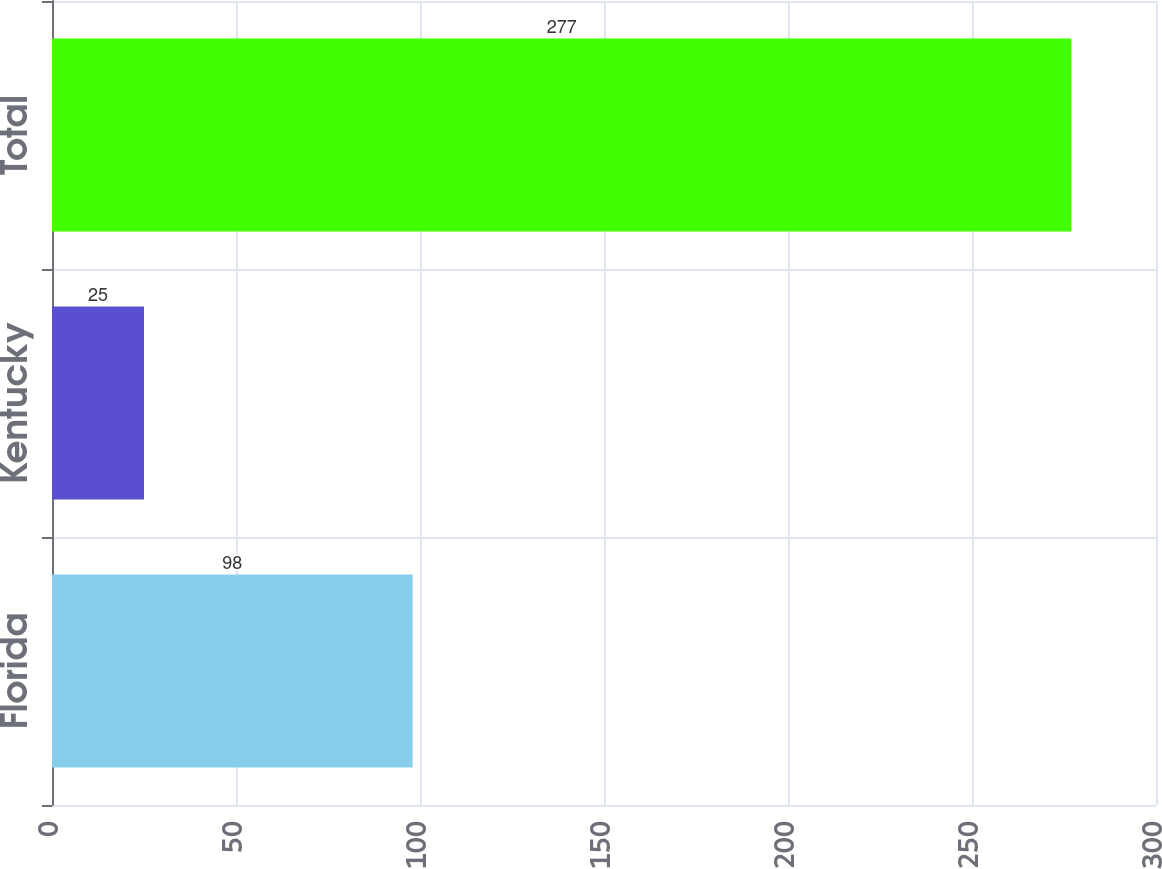Convert chart to OTSL. <chart><loc_0><loc_0><loc_500><loc_500><bar_chart><fcel>Florida<fcel>Kentucky<fcel>Total<nl><fcel>98<fcel>25<fcel>277<nl></chart> 